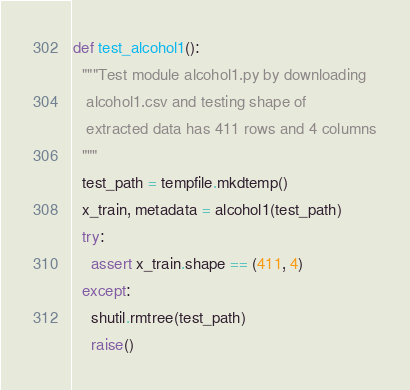Convert code to text. <code><loc_0><loc_0><loc_500><loc_500><_Python_>

def test_alcohol1():
  """Test module alcohol1.py by downloading
   alcohol1.csv and testing shape of
   extracted data has 411 rows and 4 columns
  """
  test_path = tempfile.mkdtemp()
  x_train, metadata = alcohol1(test_path)
  try:
    assert x_train.shape == (411, 4)
  except:
    shutil.rmtree(test_path)
    raise()
</code> 